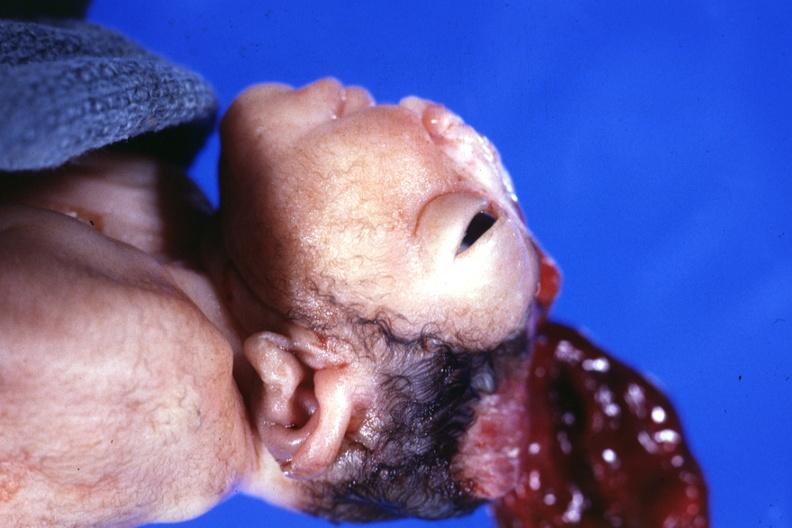does there show lateral view close-up typical?
Answer the question using a single word or phrase. No 